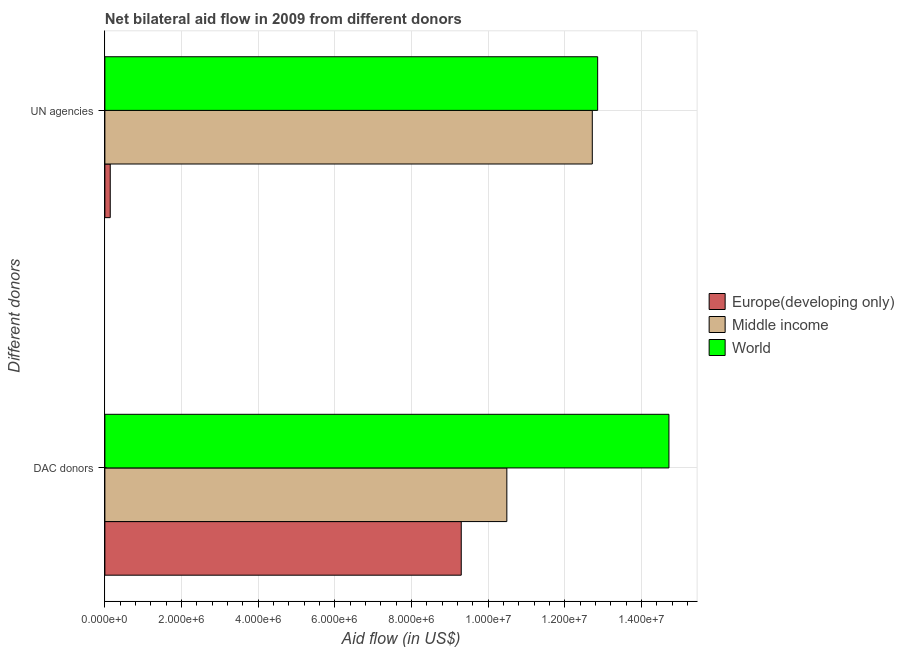How many different coloured bars are there?
Provide a succinct answer. 3. Are the number of bars on each tick of the Y-axis equal?
Offer a very short reply. Yes. How many bars are there on the 2nd tick from the top?
Offer a very short reply. 3. How many bars are there on the 2nd tick from the bottom?
Offer a very short reply. 3. What is the label of the 2nd group of bars from the top?
Make the answer very short. DAC donors. What is the aid flow from dac donors in Europe(developing only)?
Your response must be concise. 9.30e+06. Across all countries, what is the maximum aid flow from dac donors?
Keep it short and to the point. 1.47e+07. Across all countries, what is the minimum aid flow from dac donors?
Provide a short and direct response. 9.30e+06. In which country was the aid flow from dac donors maximum?
Provide a short and direct response. World. In which country was the aid flow from un agencies minimum?
Offer a very short reply. Europe(developing only). What is the total aid flow from dac donors in the graph?
Your answer should be very brief. 3.45e+07. What is the difference between the aid flow from un agencies in Europe(developing only) and that in World?
Offer a very short reply. -1.27e+07. What is the difference between the aid flow from un agencies in World and the aid flow from dac donors in Middle income?
Your answer should be very brief. 2.37e+06. What is the average aid flow from un agencies per country?
Ensure brevity in your answer.  8.57e+06. What is the difference between the aid flow from un agencies and aid flow from dac donors in Europe(developing only)?
Ensure brevity in your answer.  -9.16e+06. In how many countries, is the aid flow from un agencies greater than 14400000 US$?
Make the answer very short. 0. What is the ratio of the aid flow from un agencies in Europe(developing only) to that in World?
Give a very brief answer. 0.01. Is the aid flow from dac donors in Middle income less than that in Europe(developing only)?
Offer a terse response. No. What does the 2nd bar from the top in UN agencies represents?
Offer a terse response. Middle income. How many legend labels are there?
Make the answer very short. 3. What is the title of the graph?
Give a very brief answer. Net bilateral aid flow in 2009 from different donors. What is the label or title of the X-axis?
Give a very brief answer. Aid flow (in US$). What is the label or title of the Y-axis?
Provide a succinct answer. Different donors. What is the Aid flow (in US$) in Europe(developing only) in DAC donors?
Offer a terse response. 9.30e+06. What is the Aid flow (in US$) in Middle income in DAC donors?
Provide a short and direct response. 1.05e+07. What is the Aid flow (in US$) in World in DAC donors?
Your answer should be very brief. 1.47e+07. What is the Aid flow (in US$) of Europe(developing only) in UN agencies?
Give a very brief answer. 1.40e+05. What is the Aid flow (in US$) of Middle income in UN agencies?
Your response must be concise. 1.27e+07. What is the Aid flow (in US$) in World in UN agencies?
Your answer should be compact. 1.29e+07. Across all Different donors, what is the maximum Aid flow (in US$) in Europe(developing only)?
Your response must be concise. 9.30e+06. Across all Different donors, what is the maximum Aid flow (in US$) of Middle income?
Keep it short and to the point. 1.27e+07. Across all Different donors, what is the maximum Aid flow (in US$) in World?
Provide a short and direct response. 1.47e+07. Across all Different donors, what is the minimum Aid flow (in US$) of Europe(developing only)?
Provide a succinct answer. 1.40e+05. Across all Different donors, what is the minimum Aid flow (in US$) in Middle income?
Offer a terse response. 1.05e+07. Across all Different donors, what is the minimum Aid flow (in US$) in World?
Offer a terse response. 1.29e+07. What is the total Aid flow (in US$) in Europe(developing only) in the graph?
Ensure brevity in your answer.  9.44e+06. What is the total Aid flow (in US$) in Middle income in the graph?
Make the answer very short. 2.32e+07. What is the total Aid flow (in US$) of World in the graph?
Your response must be concise. 2.76e+07. What is the difference between the Aid flow (in US$) of Europe(developing only) in DAC donors and that in UN agencies?
Keep it short and to the point. 9.16e+06. What is the difference between the Aid flow (in US$) in Middle income in DAC donors and that in UN agencies?
Your answer should be compact. -2.23e+06. What is the difference between the Aid flow (in US$) in World in DAC donors and that in UN agencies?
Ensure brevity in your answer.  1.86e+06. What is the difference between the Aid flow (in US$) in Europe(developing only) in DAC donors and the Aid flow (in US$) in Middle income in UN agencies?
Ensure brevity in your answer.  -3.42e+06. What is the difference between the Aid flow (in US$) in Europe(developing only) in DAC donors and the Aid flow (in US$) in World in UN agencies?
Provide a succinct answer. -3.56e+06. What is the difference between the Aid flow (in US$) of Middle income in DAC donors and the Aid flow (in US$) of World in UN agencies?
Ensure brevity in your answer.  -2.37e+06. What is the average Aid flow (in US$) in Europe(developing only) per Different donors?
Your answer should be compact. 4.72e+06. What is the average Aid flow (in US$) in Middle income per Different donors?
Offer a terse response. 1.16e+07. What is the average Aid flow (in US$) in World per Different donors?
Your response must be concise. 1.38e+07. What is the difference between the Aid flow (in US$) in Europe(developing only) and Aid flow (in US$) in Middle income in DAC donors?
Make the answer very short. -1.19e+06. What is the difference between the Aid flow (in US$) in Europe(developing only) and Aid flow (in US$) in World in DAC donors?
Provide a short and direct response. -5.42e+06. What is the difference between the Aid flow (in US$) in Middle income and Aid flow (in US$) in World in DAC donors?
Your answer should be very brief. -4.23e+06. What is the difference between the Aid flow (in US$) of Europe(developing only) and Aid flow (in US$) of Middle income in UN agencies?
Give a very brief answer. -1.26e+07. What is the difference between the Aid flow (in US$) in Europe(developing only) and Aid flow (in US$) in World in UN agencies?
Keep it short and to the point. -1.27e+07. What is the ratio of the Aid flow (in US$) of Europe(developing only) in DAC donors to that in UN agencies?
Make the answer very short. 66.43. What is the ratio of the Aid flow (in US$) in Middle income in DAC donors to that in UN agencies?
Offer a terse response. 0.82. What is the ratio of the Aid flow (in US$) in World in DAC donors to that in UN agencies?
Make the answer very short. 1.14. What is the difference between the highest and the second highest Aid flow (in US$) in Europe(developing only)?
Provide a succinct answer. 9.16e+06. What is the difference between the highest and the second highest Aid flow (in US$) in Middle income?
Provide a short and direct response. 2.23e+06. What is the difference between the highest and the second highest Aid flow (in US$) of World?
Your answer should be very brief. 1.86e+06. What is the difference between the highest and the lowest Aid flow (in US$) in Europe(developing only)?
Ensure brevity in your answer.  9.16e+06. What is the difference between the highest and the lowest Aid flow (in US$) of Middle income?
Give a very brief answer. 2.23e+06. What is the difference between the highest and the lowest Aid flow (in US$) in World?
Provide a short and direct response. 1.86e+06. 